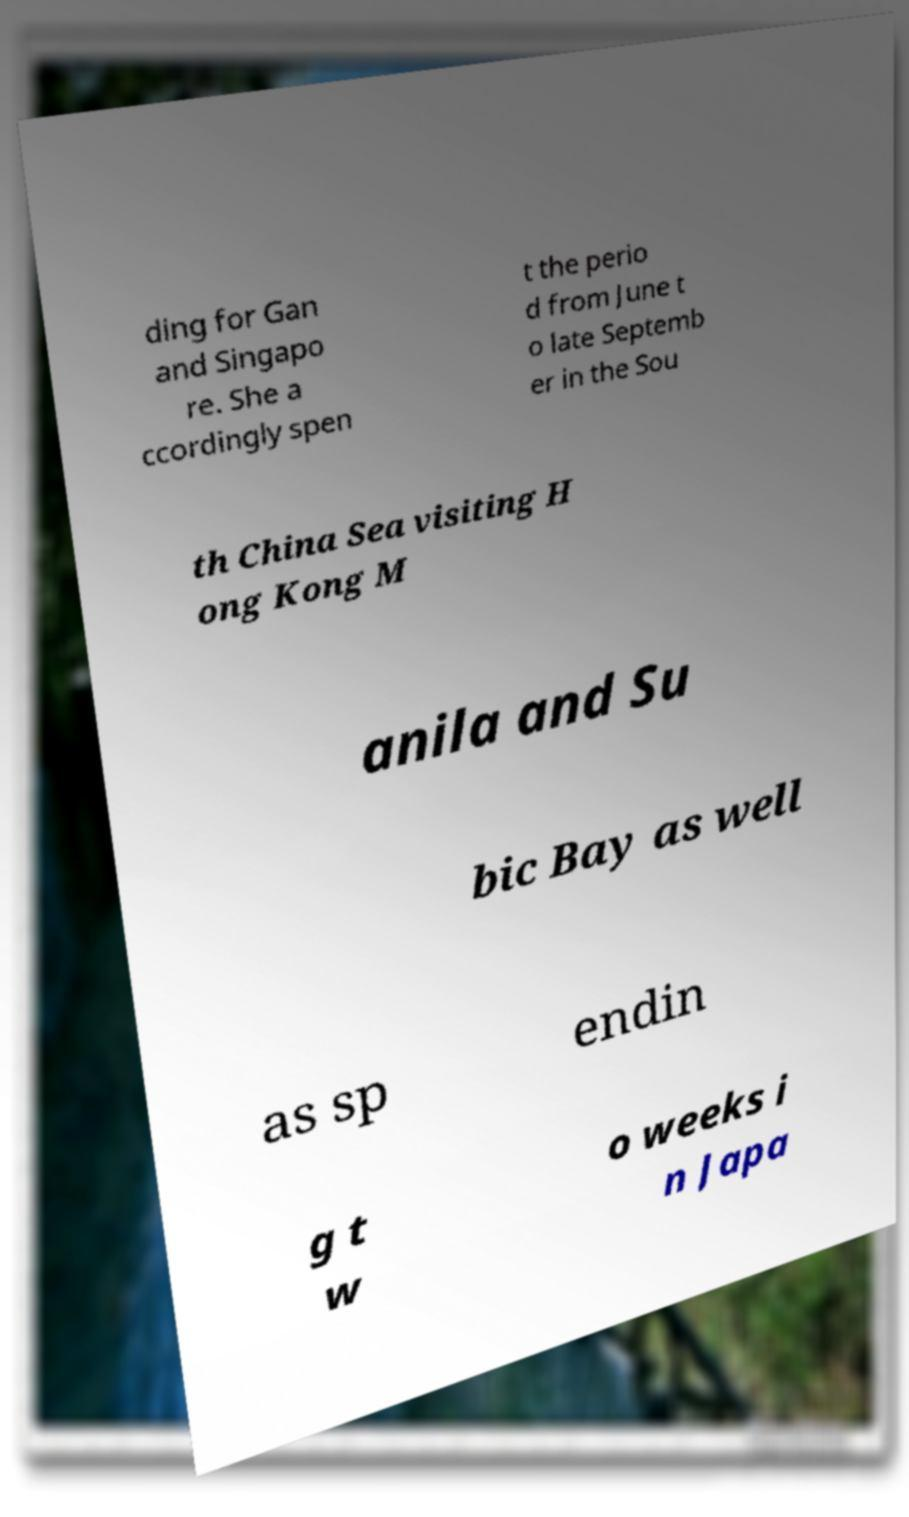What messages or text are displayed in this image? I need them in a readable, typed format. ding for Gan and Singapo re. She a ccordingly spen t the perio d from June t o late Septemb er in the Sou th China Sea visiting H ong Kong M anila and Su bic Bay as well as sp endin g t w o weeks i n Japa 